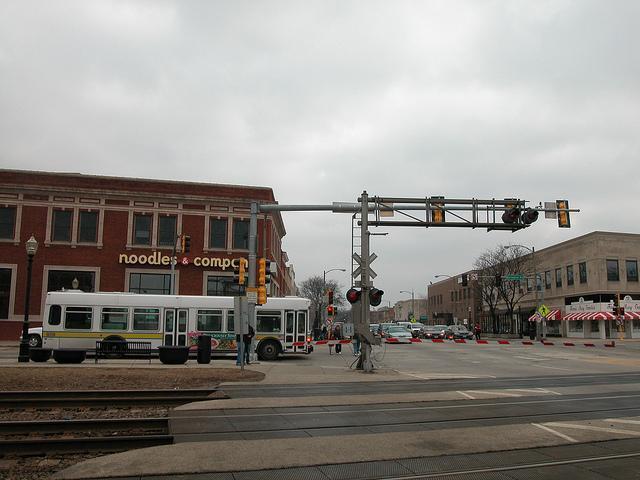How many bikes are there?
Give a very brief answer. 0. How many garbage cans do you see?
Give a very brief answer. 1. How many floors does the building have?
Give a very brief answer. 2. How many stories tall is the building on the left?
Give a very brief answer. 2. How many types of vehicles are in the photo?
Give a very brief answer. 2. How many books do you see?
Give a very brief answer. 0. 